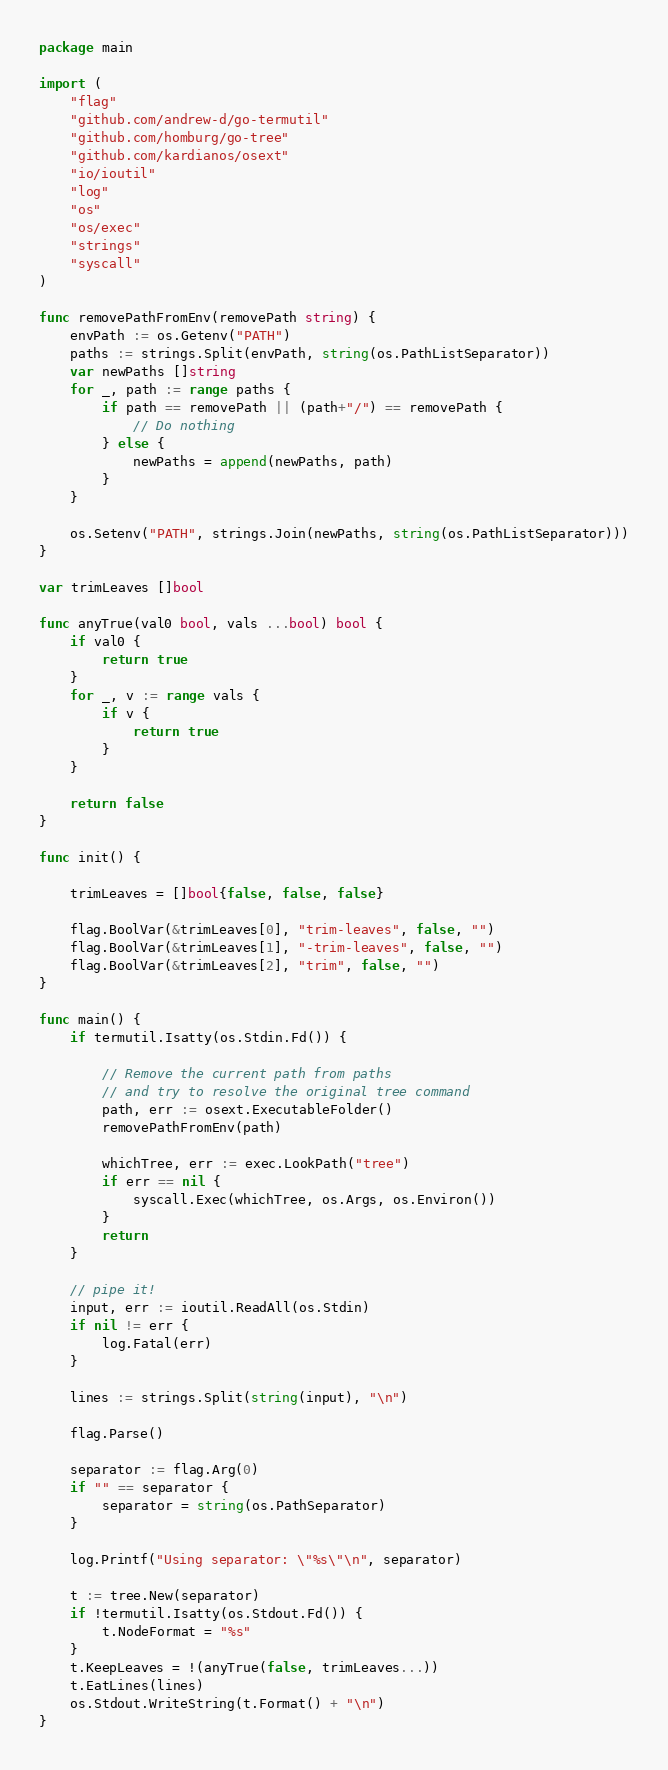Convert code to text. <code><loc_0><loc_0><loc_500><loc_500><_Go_>package main

import (
	"flag"
	"github.com/andrew-d/go-termutil"
	"github.com/homburg/go-tree"
	"github.com/kardianos/osext"
	"io/ioutil"
	"log"
	"os"
	"os/exec"
	"strings"
	"syscall"
)

func removePathFromEnv(removePath string) {
	envPath := os.Getenv("PATH")
	paths := strings.Split(envPath, string(os.PathListSeparator))
	var newPaths []string
	for _, path := range paths {
		if path == removePath || (path+"/") == removePath {
			// Do nothing
		} else {
			newPaths = append(newPaths, path)
		}
	}

	os.Setenv("PATH", strings.Join(newPaths, string(os.PathListSeparator)))
}

var trimLeaves []bool

func anyTrue(val0 bool, vals ...bool) bool {
	if val0 {
		return true
	}
	for _, v := range vals {
		if v {
			return true
		}
	}

	return false
}

func init() {

	trimLeaves = []bool{false, false, false}

	flag.BoolVar(&trimLeaves[0], "trim-leaves", false, "")
	flag.BoolVar(&trimLeaves[1], "-trim-leaves", false, "")
	flag.BoolVar(&trimLeaves[2], "trim", false, "")
}

func main() {
	if termutil.Isatty(os.Stdin.Fd()) {

		// Remove the current path from paths
		// and try to resolve the original tree command
		path, err := osext.ExecutableFolder()
		removePathFromEnv(path)

		whichTree, err := exec.LookPath("tree")
		if err == nil {
			syscall.Exec(whichTree, os.Args, os.Environ())
		}
		return
	}

	// pipe it!
	input, err := ioutil.ReadAll(os.Stdin)
	if nil != err {
		log.Fatal(err)
	}

	lines := strings.Split(string(input), "\n")

	flag.Parse()

	separator := flag.Arg(0)
	if "" == separator {
		separator = string(os.PathSeparator)
	}

	log.Printf("Using separator: \"%s\"\n", separator)

	t := tree.New(separator)
	if !termutil.Isatty(os.Stdout.Fd()) {
		t.NodeFormat = "%s"
	}
	t.KeepLeaves = !(anyTrue(false, trimLeaves...))
	t.EatLines(lines)
	os.Stdout.WriteString(t.Format() + "\n")
}
</code> 